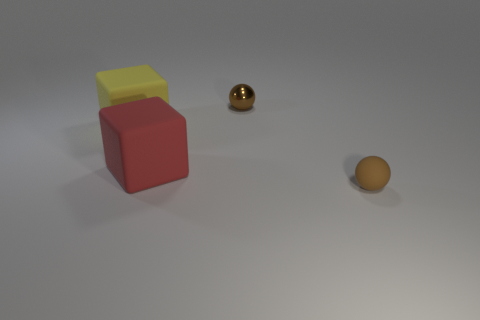Add 4 red objects. How many objects exist? 8 Subtract 1 balls. How many balls are left? 1 Subtract all gray spheres. Subtract all red cylinders. How many spheres are left? 2 Subtract all big yellow matte blocks. Subtract all cyan rubber cylinders. How many objects are left? 3 Add 1 large things. How many large things are left? 3 Add 4 yellow matte blocks. How many yellow matte blocks exist? 5 Subtract 0 green balls. How many objects are left? 4 